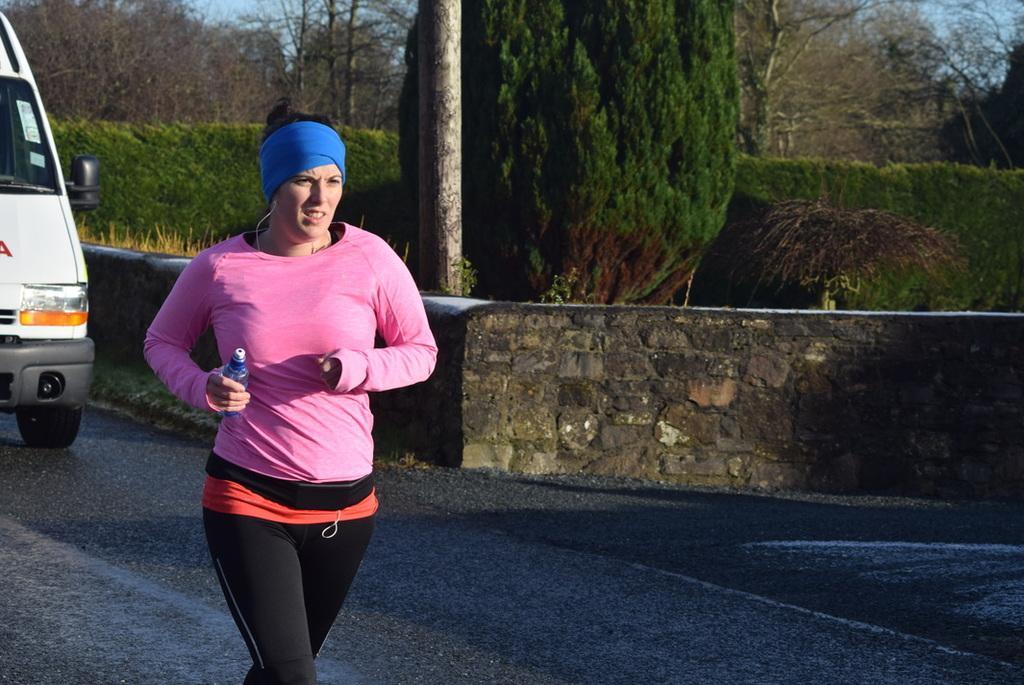Describe this image in one or two sentences. This picture shows a woman running holding a bottle in her hand and a headband to her head and we see trees and vehicle on the road and we see a wall. 